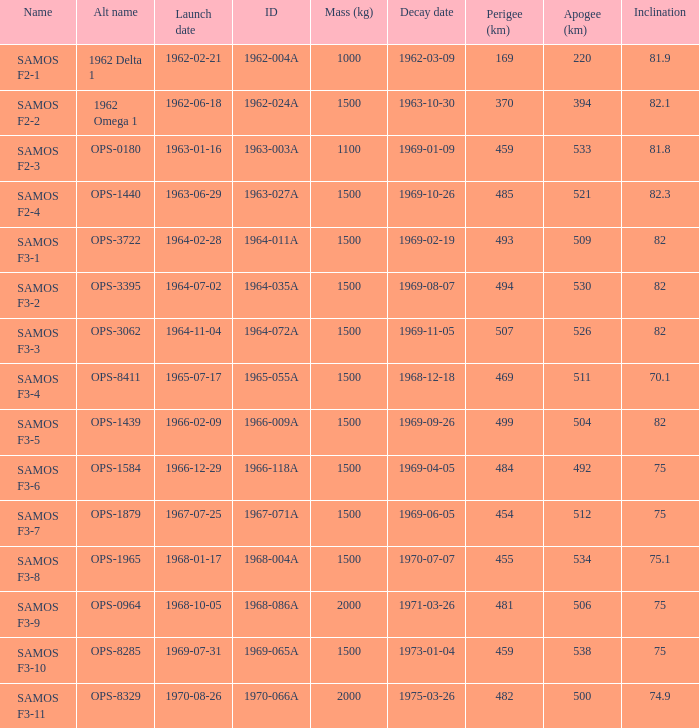What is the slant when the secondary identifier is ops-1584? 75.0. 